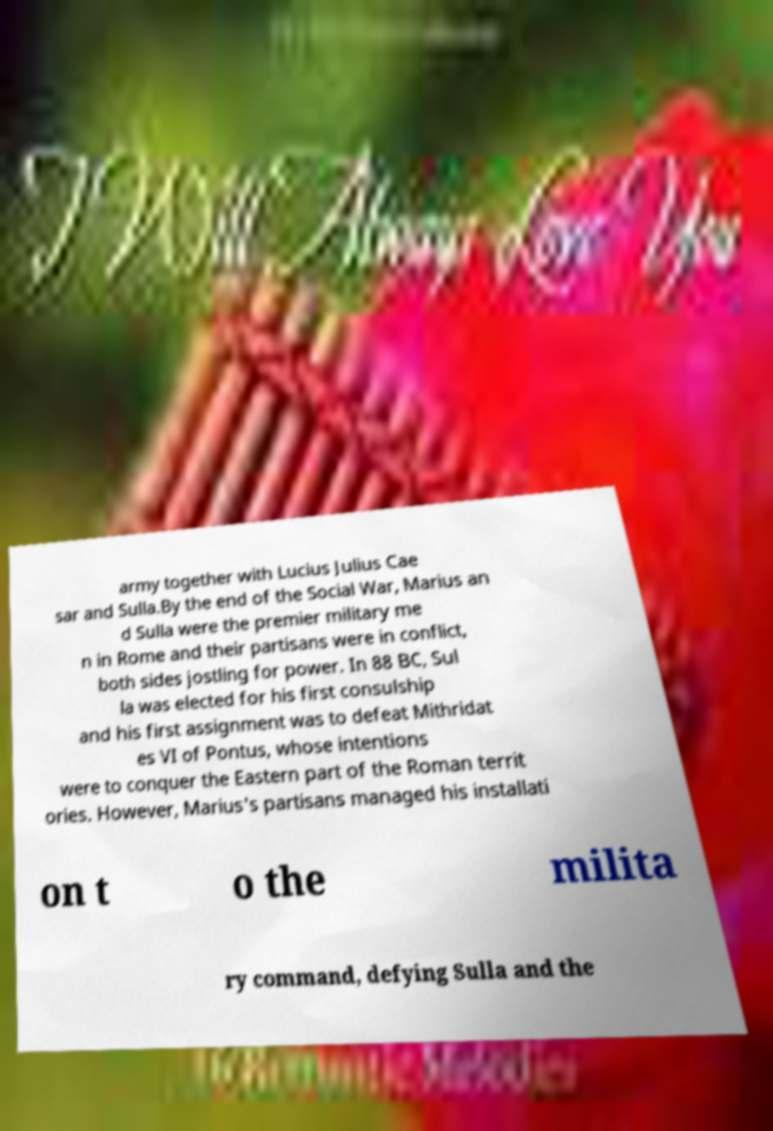For documentation purposes, I need the text within this image transcribed. Could you provide that? army together with Lucius Julius Cae sar and Sulla.By the end of the Social War, Marius an d Sulla were the premier military me n in Rome and their partisans were in conflict, both sides jostling for power. In 88 BC, Sul la was elected for his first consulship and his first assignment was to defeat Mithridat es VI of Pontus, whose intentions were to conquer the Eastern part of the Roman territ ories. However, Marius's partisans managed his installati on t o the milita ry command, defying Sulla and the 